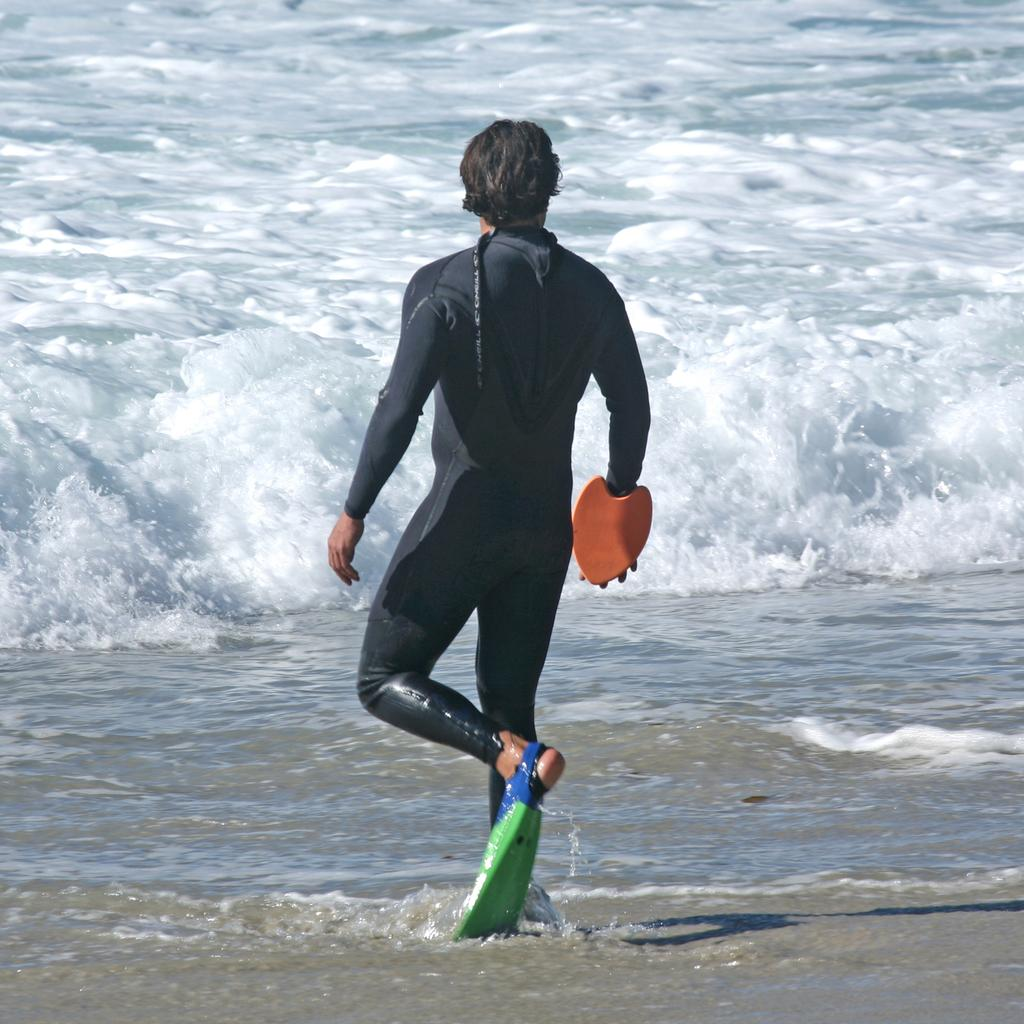What is the main subject of the image? There is a man in the image. What is the man doing in the image? The man is walking into the water. What is the man wearing in the image? The man is wearing a black color dress. What type of iron can be seen in the man's hand in the image? There is no iron present in the image; the man is walking into the water wearing a black dress. 